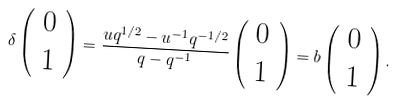Convert formula to latex. <formula><loc_0><loc_0><loc_500><loc_500>\delta \left ( \begin{array} { c } 0 \\ 1 \end{array} \right ) = \frac { u q ^ { 1 / 2 } - u ^ { - 1 } q ^ { - 1 / 2 } } { q - q ^ { - 1 } } \left ( \begin{array} { c } 0 \\ 1 \end{array} \right ) = b \left ( \begin{array} { c } 0 \\ 1 \end{array} \right ) .</formula> 